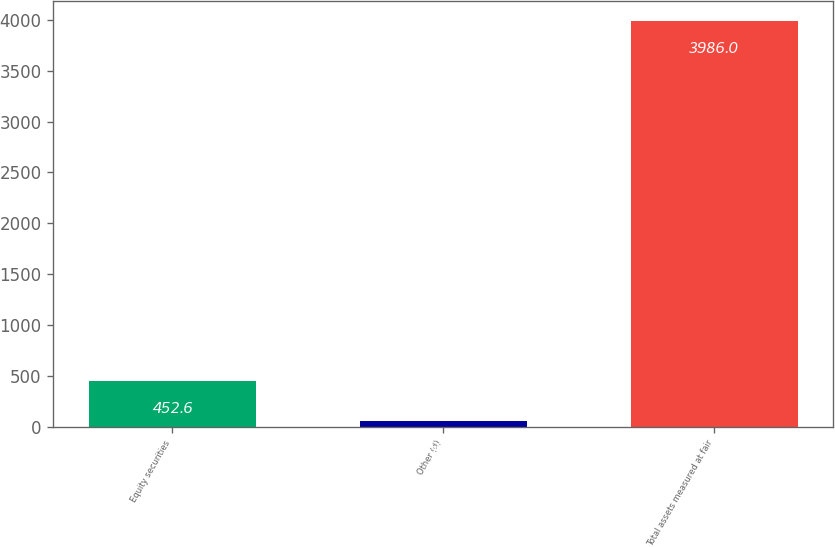Convert chart. <chart><loc_0><loc_0><loc_500><loc_500><bar_chart><fcel>Equity securities<fcel>Other (d)<fcel>Total assets measured at fair<nl><fcel>452.6<fcel>60<fcel>3986<nl></chart> 